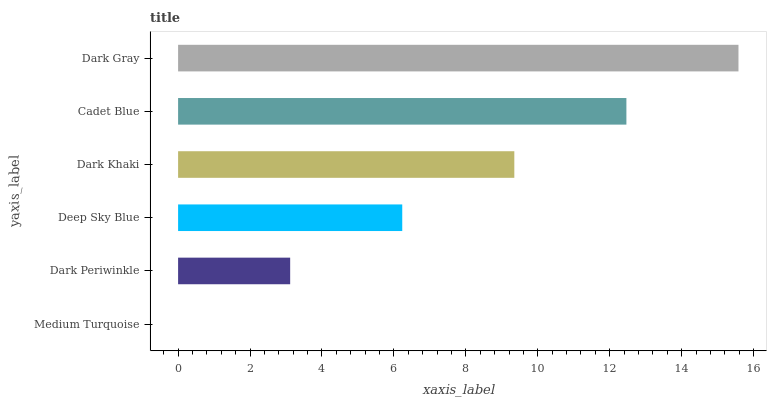Is Medium Turquoise the minimum?
Answer yes or no. Yes. Is Dark Gray the maximum?
Answer yes or no. Yes. Is Dark Periwinkle the minimum?
Answer yes or no. No. Is Dark Periwinkle the maximum?
Answer yes or no. No. Is Dark Periwinkle greater than Medium Turquoise?
Answer yes or no. Yes. Is Medium Turquoise less than Dark Periwinkle?
Answer yes or no. Yes. Is Medium Turquoise greater than Dark Periwinkle?
Answer yes or no. No. Is Dark Periwinkle less than Medium Turquoise?
Answer yes or no. No. Is Dark Khaki the high median?
Answer yes or no. Yes. Is Deep Sky Blue the low median?
Answer yes or no. Yes. Is Dark Gray the high median?
Answer yes or no. No. Is Dark Gray the low median?
Answer yes or no. No. 